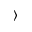<formula> <loc_0><loc_0><loc_500><loc_500>\rangle</formula> 